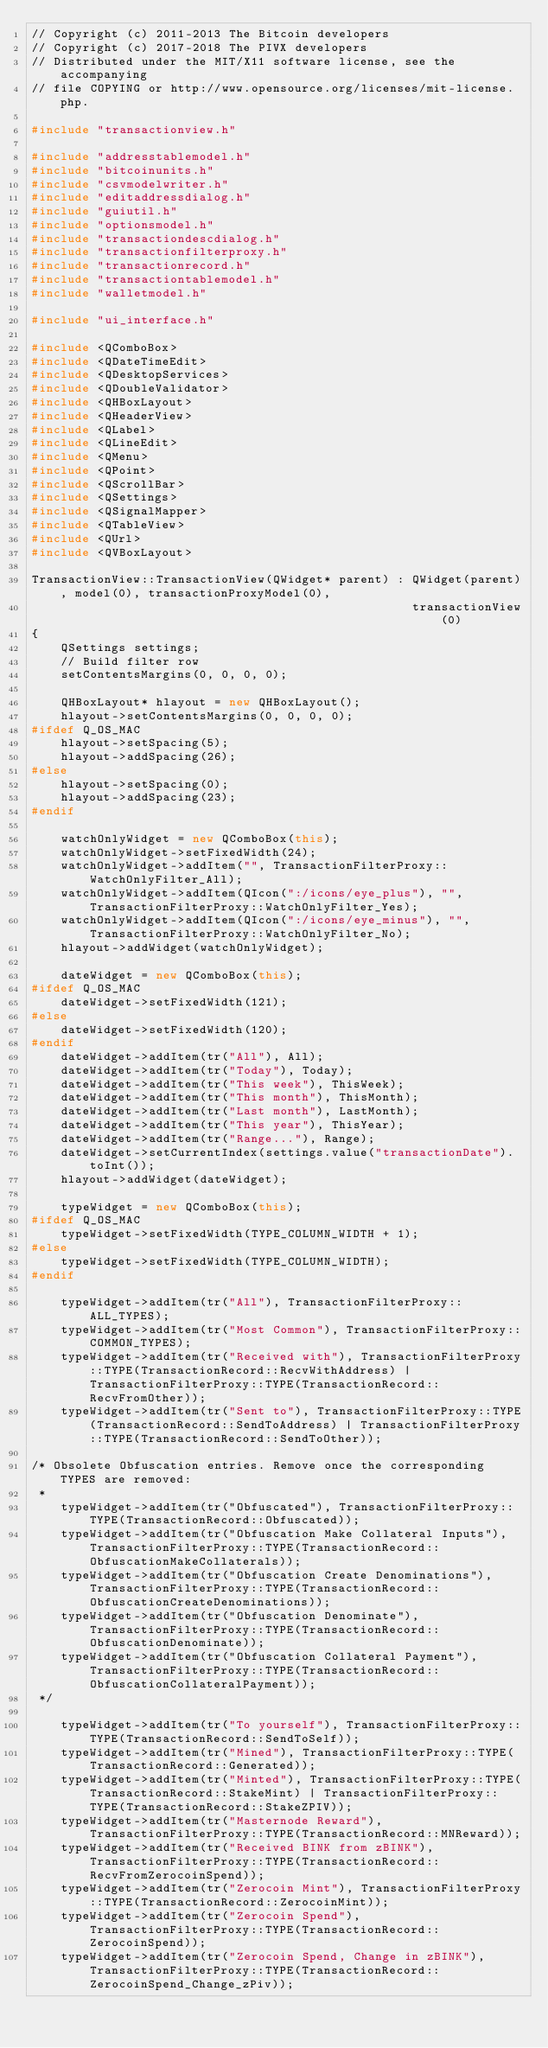Convert code to text. <code><loc_0><loc_0><loc_500><loc_500><_C++_>// Copyright (c) 2011-2013 The Bitcoin developers
// Copyright (c) 2017-2018 The PIVX developers
// Distributed under the MIT/X11 software license, see the accompanying
// file COPYING or http://www.opensource.org/licenses/mit-license.php.

#include "transactionview.h"

#include "addresstablemodel.h"
#include "bitcoinunits.h"
#include "csvmodelwriter.h"
#include "editaddressdialog.h"
#include "guiutil.h"
#include "optionsmodel.h"
#include "transactiondescdialog.h"
#include "transactionfilterproxy.h"
#include "transactionrecord.h"
#include "transactiontablemodel.h"
#include "walletmodel.h"

#include "ui_interface.h"

#include <QComboBox>
#include <QDateTimeEdit>
#include <QDesktopServices>
#include <QDoubleValidator>
#include <QHBoxLayout>
#include <QHeaderView>
#include <QLabel>
#include <QLineEdit>
#include <QMenu>
#include <QPoint>
#include <QScrollBar>
#include <QSettings>
#include <QSignalMapper>
#include <QTableView>
#include <QUrl>
#include <QVBoxLayout>

TransactionView::TransactionView(QWidget* parent) : QWidget(parent), model(0), transactionProxyModel(0),
                                                    transactionView(0)
{
    QSettings settings;
    // Build filter row
    setContentsMargins(0, 0, 0, 0);

    QHBoxLayout* hlayout = new QHBoxLayout();
    hlayout->setContentsMargins(0, 0, 0, 0);
#ifdef Q_OS_MAC
    hlayout->setSpacing(5);
    hlayout->addSpacing(26);
#else
    hlayout->setSpacing(0);
    hlayout->addSpacing(23);
#endif

    watchOnlyWidget = new QComboBox(this);
    watchOnlyWidget->setFixedWidth(24);
    watchOnlyWidget->addItem("", TransactionFilterProxy::WatchOnlyFilter_All);
    watchOnlyWidget->addItem(QIcon(":/icons/eye_plus"), "", TransactionFilterProxy::WatchOnlyFilter_Yes);
    watchOnlyWidget->addItem(QIcon(":/icons/eye_minus"), "", TransactionFilterProxy::WatchOnlyFilter_No);
    hlayout->addWidget(watchOnlyWidget);

    dateWidget = new QComboBox(this);
#ifdef Q_OS_MAC
    dateWidget->setFixedWidth(121);
#else
    dateWidget->setFixedWidth(120);
#endif
    dateWidget->addItem(tr("All"), All);
    dateWidget->addItem(tr("Today"), Today);
    dateWidget->addItem(tr("This week"), ThisWeek);
    dateWidget->addItem(tr("This month"), ThisMonth);
    dateWidget->addItem(tr("Last month"), LastMonth);
    dateWidget->addItem(tr("This year"), ThisYear);
    dateWidget->addItem(tr("Range..."), Range);
    dateWidget->setCurrentIndex(settings.value("transactionDate").toInt());
    hlayout->addWidget(dateWidget);

    typeWidget = new QComboBox(this);
#ifdef Q_OS_MAC
    typeWidget->setFixedWidth(TYPE_COLUMN_WIDTH + 1);
#else
    typeWidget->setFixedWidth(TYPE_COLUMN_WIDTH);
#endif

    typeWidget->addItem(tr("All"), TransactionFilterProxy::ALL_TYPES);
    typeWidget->addItem(tr("Most Common"), TransactionFilterProxy::COMMON_TYPES);
    typeWidget->addItem(tr("Received with"), TransactionFilterProxy::TYPE(TransactionRecord::RecvWithAddress) | TransactionFilterProxy::TYPE(TransactionRecord::RecvFromOther));
    typeWidget->addItem(tr("Sent to"), TransactionFilterProxy::TYPE(TransactionRecord::SendToAddress) | TransactionFilterProxy::TYPE(TransactionRecord::SendToOther));

/* Obsolete Obfuscation entries. Remove once the corresponding TYPES are removed:
 * 
    typeWidget->addItem(tr("Obfuscated"), TransactionFilterProxy::TYPE(TransactionRecord::Obfuscated));
    typeWidget->addItem(tr("Obfuscation Make Collateral Inputs"), TransactionFilterProxy::TYPE(TransactionRecord::ObfuscationMakeCollaterals));
    typeWidget->addItem(tr("Obfuscation Create Denominations"), TransactionFilterProxy::TYPE(TransactionRecord::ObfuscationCreateDenominations));
    typeWidget->addItem(tr("Obfuscation Denominate"), TransactionFilterProxy::TYPE(TransactionRecord::ObfuscationDenominate));
    typeWidget->addItem(tr("Obfuscation Collateral Payment"), TransactionFilterProxy::TYPE(TransactionRecord::ObfuscationCollateralPayment));
 */

    typeWidget->addItem(tr("To yourself"), TransactionFilterProxy::TYPE(TransactionRecord::SendToSelf));
    typeWidget->addItem(tr("Mined"), TransactionFilterProxy::TYPE(TransactionRecord::Generated));
    typeWidget->addItem(tr("Minted"), TransactionFilterProxy::TYPE(TransactionRecord::StakeMint) | TransactionFilterProxy::TYPE(TransactionRecord::StakeZPIV));
    typeWidget->addItem(tr("Masternode Reward"), TransactionFilterProxy::TYPE(TransactionRecord::MNReward));
    typeWidget->addItem(tr("Received BINK from zBINK"), TransactionFilterProxy::TYPE(TransactionRecord::RecvFromZerocoinSpend));
    typeWidget->addItem(tr("Zerocoin Mint"), TransactionFilterProxy::TYPE(TransactionRecord::ZerocoinMint));
    typeWidget->addItem(tr("Zerocoin Spend"), TransactionFilterProxy::TYPE(TransactionRecord::ZerocoinSpend));
    typeWidget->addItem(tr("Zerocoin Spend, Change in zBINK"), TransactionFilterProxy::TYPE(TransactionRecord::ZerocoinSpend_Change_zPiv));</code> 